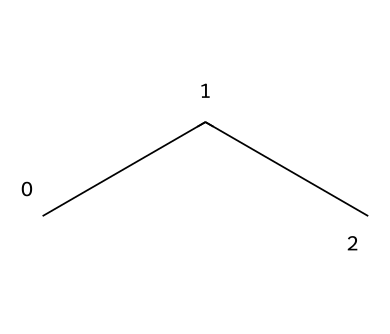What is the name of this chemical? The SMILES representation "CCC" corresponds to propane, which is a three-carbon alkane with the chemical formula C3H8.
Answer: propane How many carbon atoms are in this molecule? Analyzing the SMILES "CCC," we see three 'C' letters that represent carbon atoms, indicating that this molecule has three carbon atoms.
Answer: 3 How many hydrogen atoms are in propane? In propane, each terminal carbon typically bonds with three hydrogen atoms, while the central carbon bonds with two hydrogens. Therefore, the total number of hydrogens is eight.
Answer: 8 What type of chemical is propane classified as? Propane is classified as an alkane, which is a saturated hydrocarbon characterized by single bonds between carbon atoms.
Answer: alkane Is propane considered a greenhouse gas? While propane is a hydrocarbon and does have some greenhouse gas potential, its global warming potential is significantly lower than many other refrigerants and gases.
Answer: yes What is the primary advantage of using propane as a refrigerant? Propane's low global warming potential and high efficiency in heat absorption make it an eco-friendly refrigerant choice.
Answer: eco-friendly 